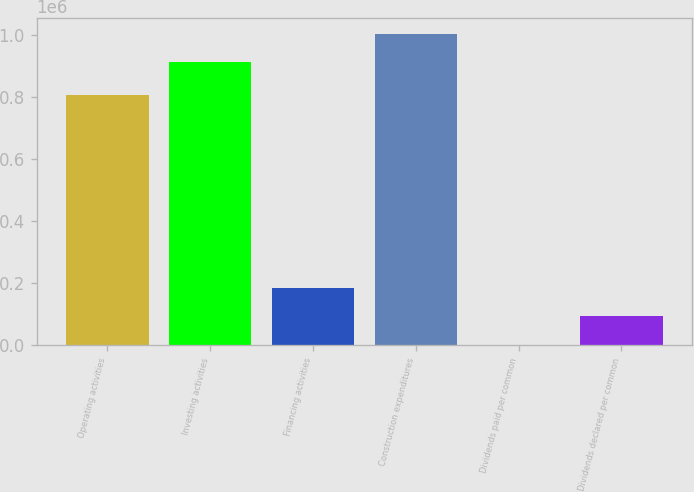<chart> <loc_0><loc_0><loc_500><loc_500><bar_chart><fcel>Operating activities<fcel>Investing activities<fcel>Financing activities<fcel>Construction expenditures<fcel>Dividends paid per common<fcel>Dividends declared per common<nl><fcel>808357<fcel>912397<fcel>184972<fcel>1.00488e+06<fcel>0.9<fcel>92486.6<nl></chart> 